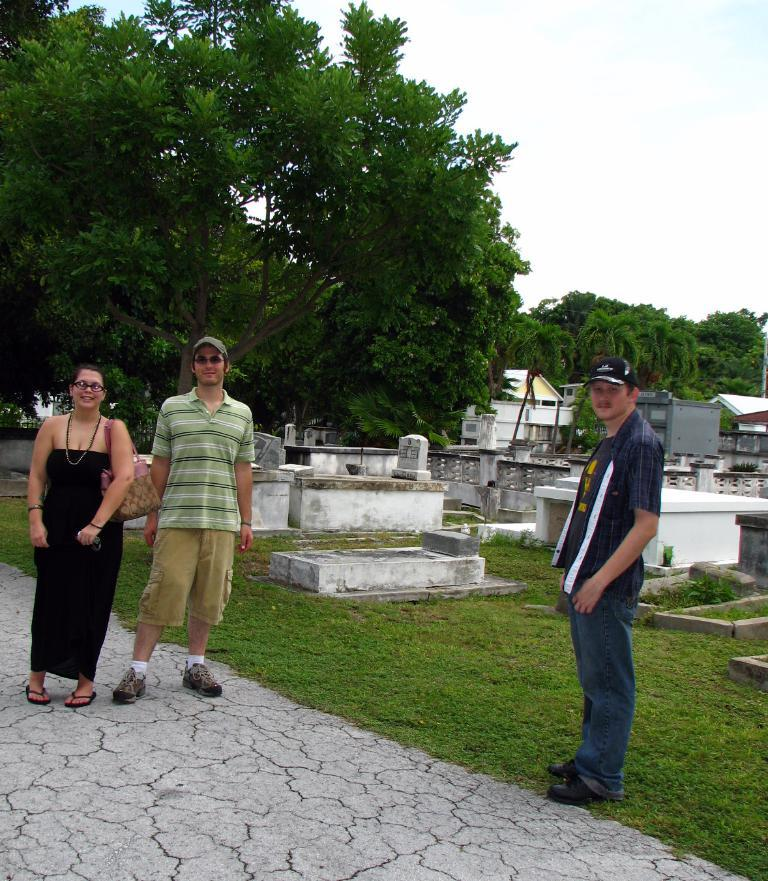What can be seen in the foreground of the image? There are people, grass, and a path in the foreground of the image. What is located in the middle of the image? There are trees, buildings, and gravestones in the middle of the image. What is visible at the top of the image? The sky is visible at the top of the image. Where is the push button for the dinner located in the image? There is no push button for dinner present in the image. What type of lunchroom can be seen in the image? There is no lunchroom present in the image. 